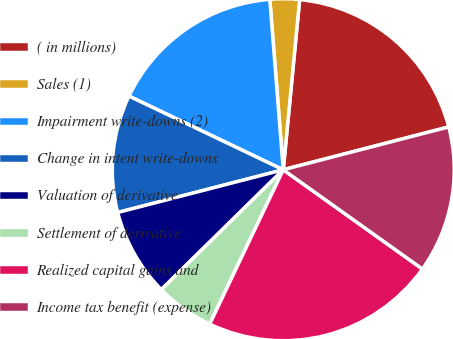<chart> <loc_0><loc_0><loc_500><loc_500><pie_chart><fcel>( in millions)<fcel>Sales (1)<fcel>Impairment write-downs (2)<fcel>Change in intent write-downs<fcel>Valuation of derivative<fcel>Settlement of derivative<fcel>Realized capital gains and<fcel>Income tax benefit (expense)<nl><fcel>19.44%<fcel>2.78%<fcel>16.66%<fcel>11.11%<fcel>8.34%<fcel>5.56%<fcel>22.22%<fcel>13.89%<nl></chart> 